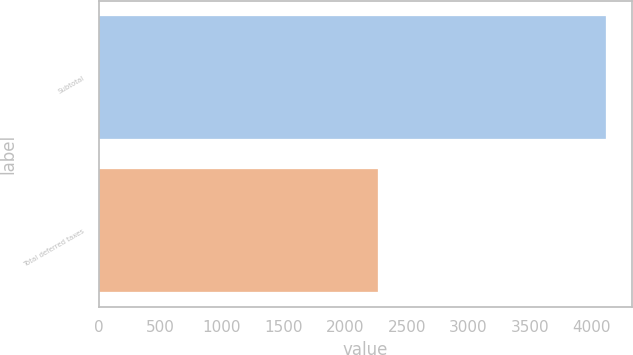Convert chart to OTSL. <chart><loc_0><loc_0><loc_500><loc_500><bar_chart><fcel>Subtotal<fcel>Total deferred taxes<nl><fcel>4120<fcel>2271<nl></chart> 